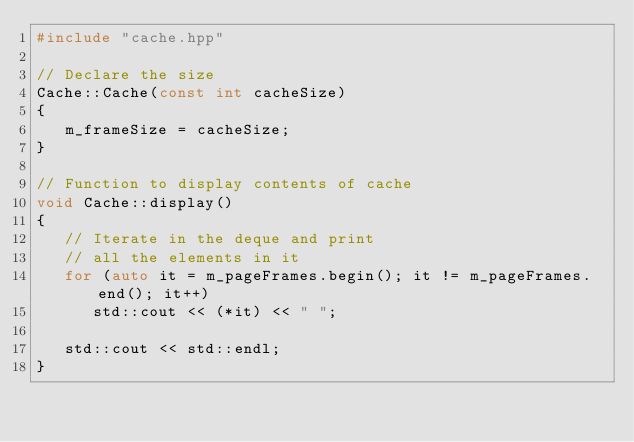<code> <loc_0><loc_0><loc_500><loc_500><_C++_>#include "cache.hpp"

// Declare the size
Cache::Cache(const int cacheSize)
{
   m_frameSize = cacheSize;
}

// Function to display contents of cache
void Cache::display()
{
   // Iterate in the deque and print
   // all the elements in it
   for (auto it = m_pageFrames.begin(); it != m_pageFrames.end(); it++)
      std::cout << (*it) << " ";

   std::cout << std::endl;
}</code> 